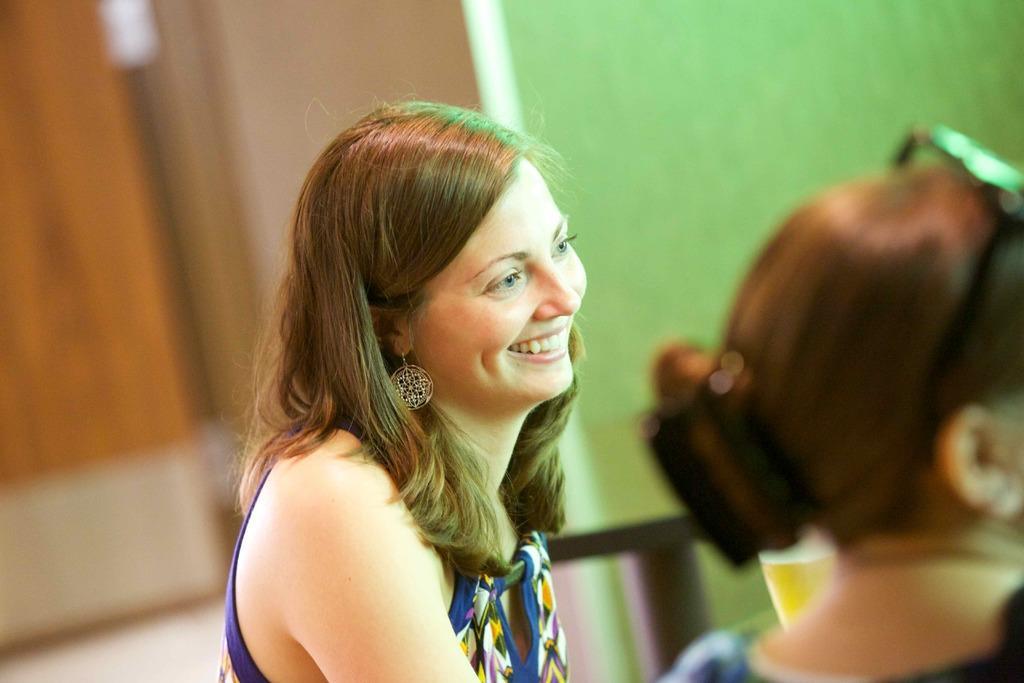How would you summarize this image in a sentence or two? Here we can see two women. In the background there are some objects and a wall. 